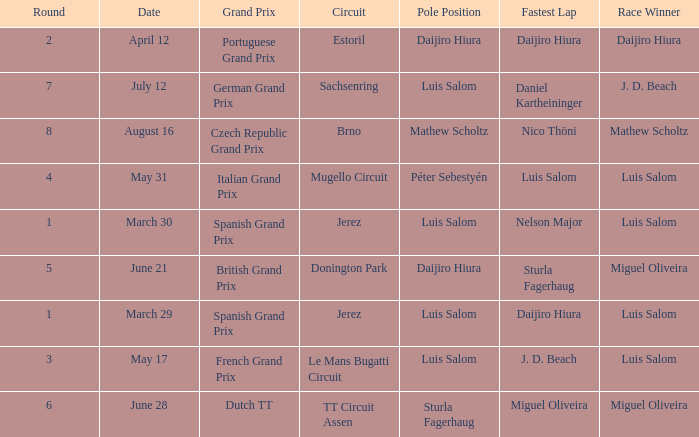What grand prixs did Daijiro Hiura win?  Portuguese Grand Prix. 